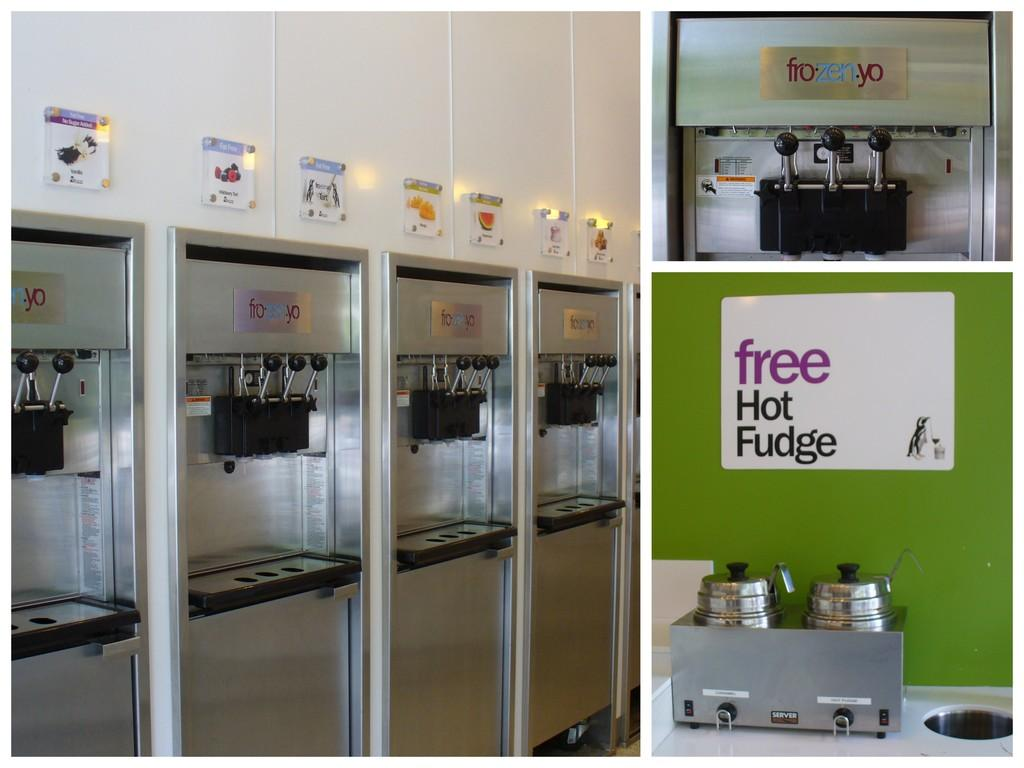<image>
Present a compact description of the photo's key features. A sign at a yogurt shop advertises "free hot fudge." 